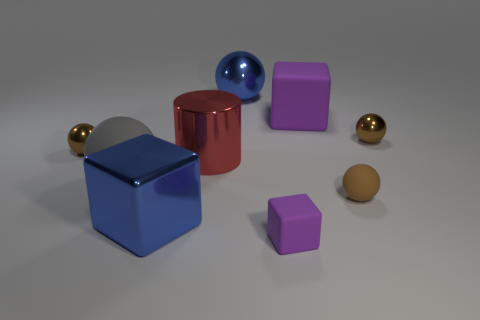Does the brown shiny thing to the right of the shiny cylinder have the same size as the big red shiny object?
Give a very brief answer. No. Is the purple cube behind the tiny block made of the same material as the tiny brown ball that is to the left of the big rubber block?
Make the answer very short. No. Are there any brown spheres of the same size as the gray rubber sphere?
Your answer should be compact. No. There is a tiny thing that is behind the tiny brown metal ball that is to the left of the big sphere to the left of the big blue ball; what shape is it?
Offer a terse response. Sphere. Is the number of large shiny objects that are in front of the blue ball greater than the number of metallic cubes?
Give a very brief answer. Yes. Is there a big purple metallic thing of the same shape as the gray rubber object?
Keep it short and to the point. No. Does the large purple block have the same material as the blue object that is in front of the big gray matte sphere?
Ensure brevity in your answer.  No. What is the color of the small matte block?
Your answer should be compact. Purple. There is a brown shiny sphere on the right side of the big metal cube on the left side of the small block; what number of brown shiny objects are in front of it?
Ensure brevity in your answer.  1. Are there any large metallic balls on the left side of the gray rubber ball?
Offer a terse response. No. 